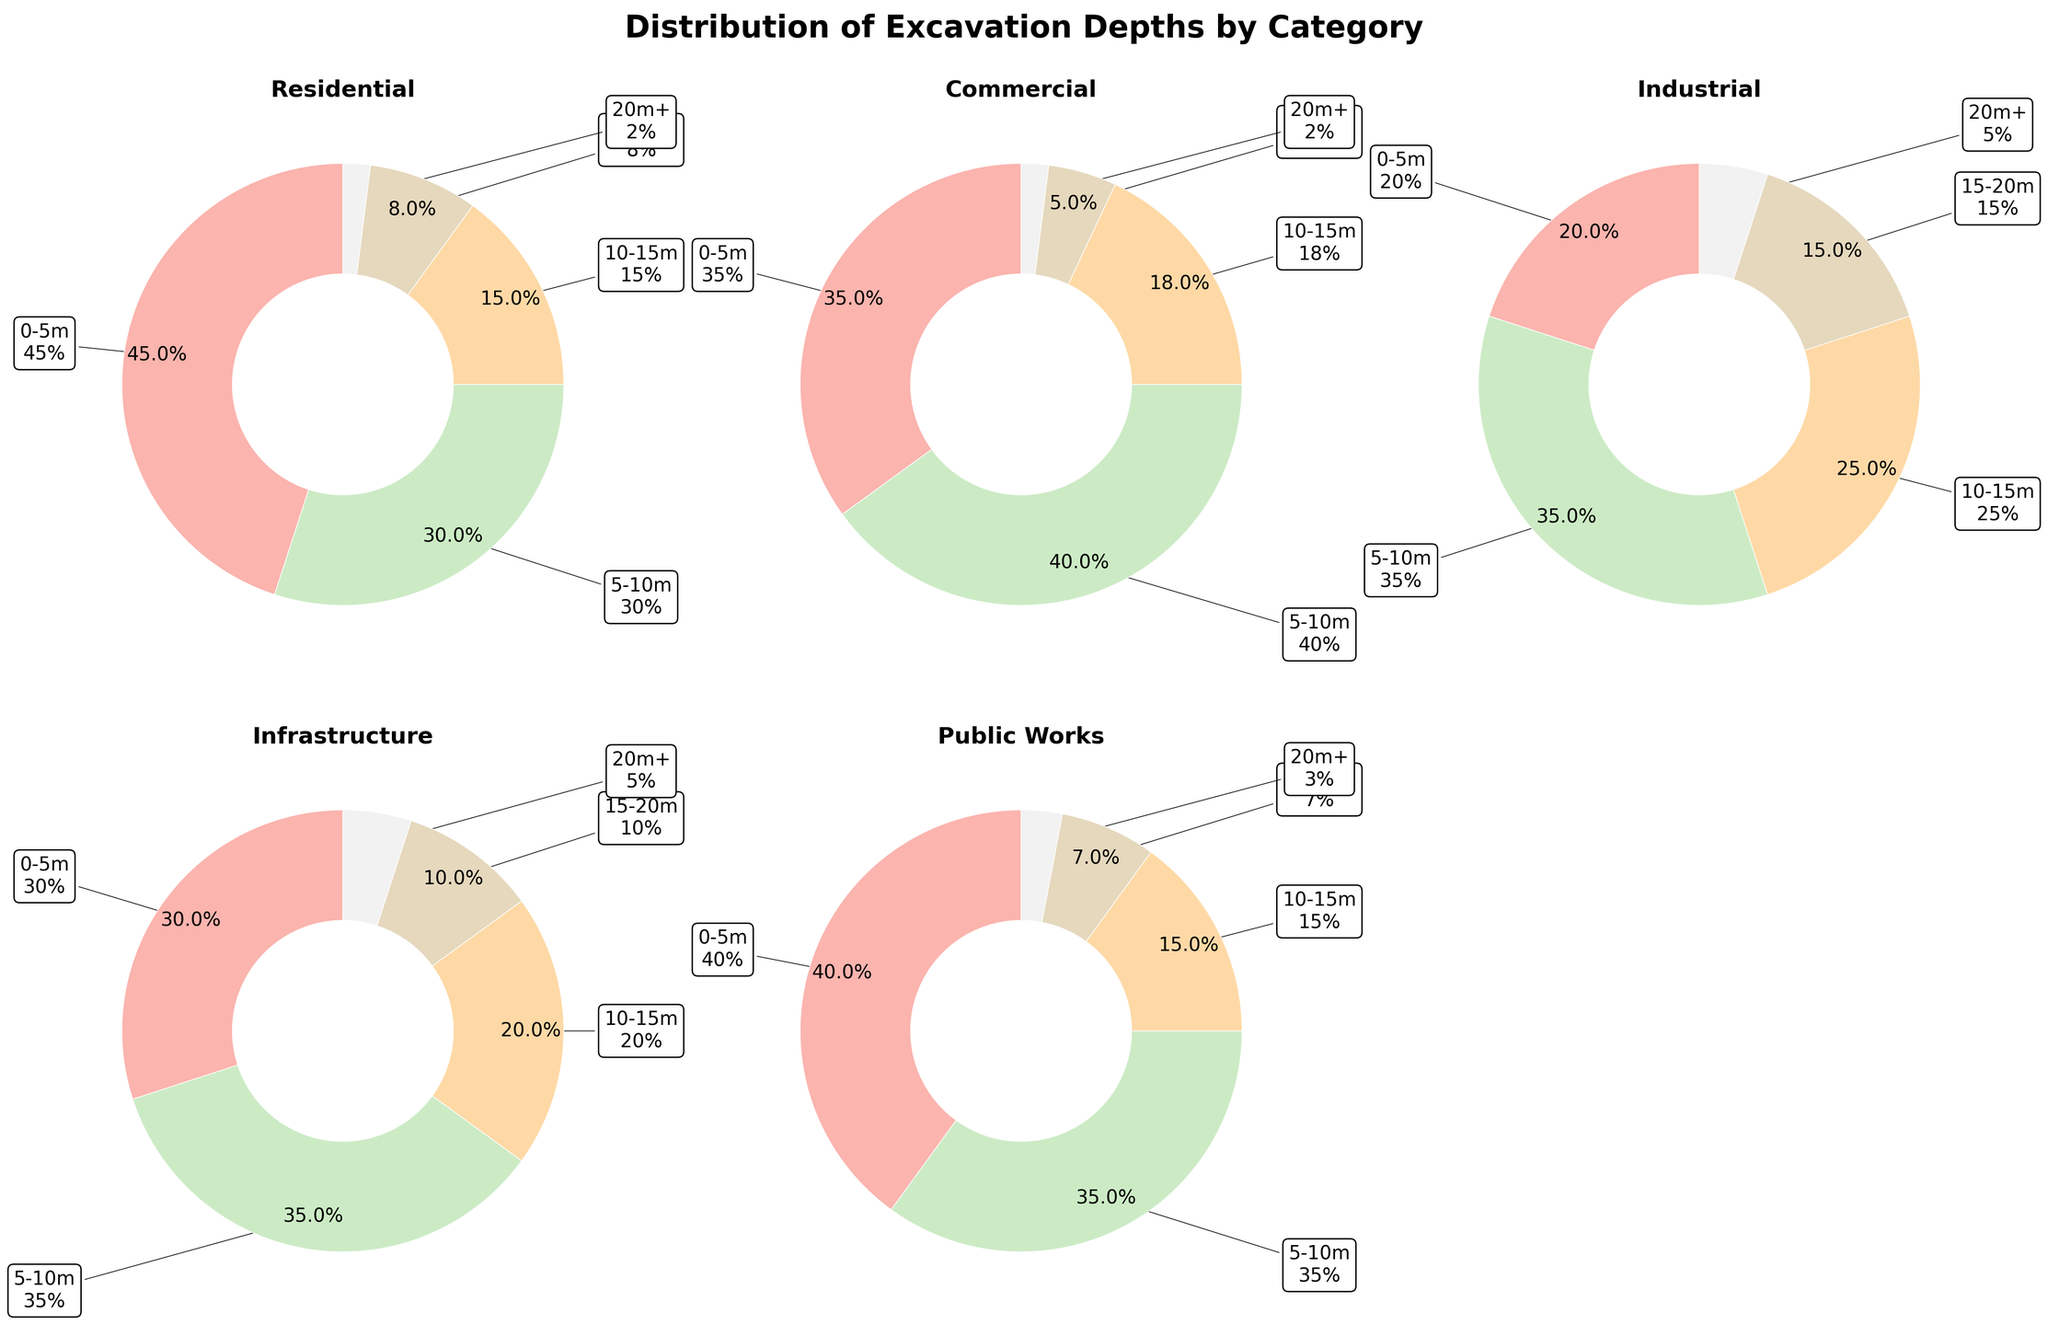What is the title of the figure? The title of the figure is displayed at the top and gives an overview of what the visual data represents. It reads "Distribution of Excavation Depths by Category".
Answer: Distribution of Excavation Depths by Category Which category has the highest proportion of 0-5m excavation projects? By examining each pie chart and looking at the largest segment colored in the lightest shade, the 'Residential' category shows the highest proportion in this segment.
Answer: Residential What percentage of Commercial excavation projects are in the 5-10m depth range? In the pie chart labeled 'Commercial', the segment for 5-10m is labeled with the percentage, which is 40%.
Answer: 40% How many categories have a segment for 20m+ excavation depths? By counting the number of pie charts that include a segment colored in darkest shade representing the 20m+ depth, the categories are 'Industrial', 'Infrastructure', and 'Public Works', which totals three.
Answer: Three What is the combined percentage of 10-15m depths in Residential and Public Works projects? The percentage for 10-15m depths in ‘Residential’ is 15% and for ‘Public Works’ is also 15%. Adding these together gives 15% + 15% = 30%.
Answer: 30% Which category has the highest variety in excavation depths? The category with the highest variety in excavation depths would have a more balanced distribution across different segments. By examining the pie charts, 'Industrial' seems to have more evenly spread percentages across all depths.
Answer: Industrial Which two categories have the same proportion of projects in the 10-15m depth range? By inspecting the pie charts for equality of the segments representing the 10-15m range, both 'Residential' and 'Public Works' categories show 15%.
Answer: Residential and Public Works What is the total number of excavation projects in the Industrial category? By summing the values in the 'Industrial' row: 20 + 35 + 25 + 15 + 5 = 100.
Answer: 100 Which category has the smallest proportion of 15-20m depth excavation projects? In each pie chart, look for the segment representing the 15-20m depth (second darkest shade). The smallest is in the 'Commercial' category with 5%.
Answer: Commercial Compare the proportions of 0-5m and 5-10m depths in Infrastructure projects. Which is greater? In 'Infrastructure', the 0-5m depth is 30% and the 5-10m depth is 35%. Thus, the 5-10m depth has a greater proportion.
Answer: 5-10m 